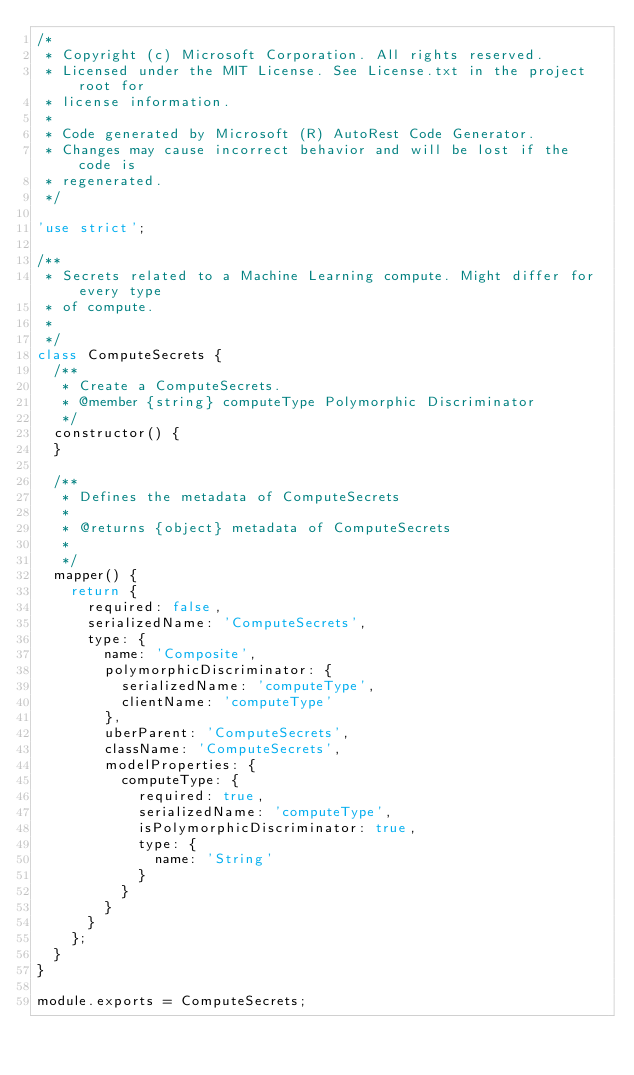<code> <loc_0><loc_0><loc_500><loc_500><_JavaScript_>/*
 * Copyright (c) Microsoft Corporation. All rights reserved.
 * Licensed under the MIT License. See License.txt in the project root for
 * license information.
 *
 * Code generated by Microsoft (R) AutoRest Code Generator.
 * Changes may cause incorrect behavior and will be lost if the code is
 * regenerated.
 */

'use strict';

/**
 * Secrets related to a Machine Learning compute. Might differ for every type
 * of compute.
 *
 */
class ComputeSecrets {
  /**
   * Create a ComputeSecrets.
   * @member {string} computeType Polymorphic Discriminator
   */
  constructor() {
  }

  /**
   * Defines the metadata of ComputeSecrets
   *
   * @returns {object} metadata of ComputeSecrets
   *
   */
  mapper() {
    return {
      required: false,
      serializedName: 'ComputeSecrets',
      type: {
        name: 'Composite',
        polymorphicDiscriminator: {
          serializedName: 'computeType',
          clientName: 'computeType'
        },
        uberParent: 'ComputeSecrets',
        className: 'ComputeSecrets',
        modelProperties: {
          computeType: {
            required: true,
            serializedName: 'computeType',
            isPolymorphicDiscriminator: true,
            type: {
              name: 'String'
            }
          }
        }
      }
    };
  }
}

module.exports = ComputeSecrets;
</code> 